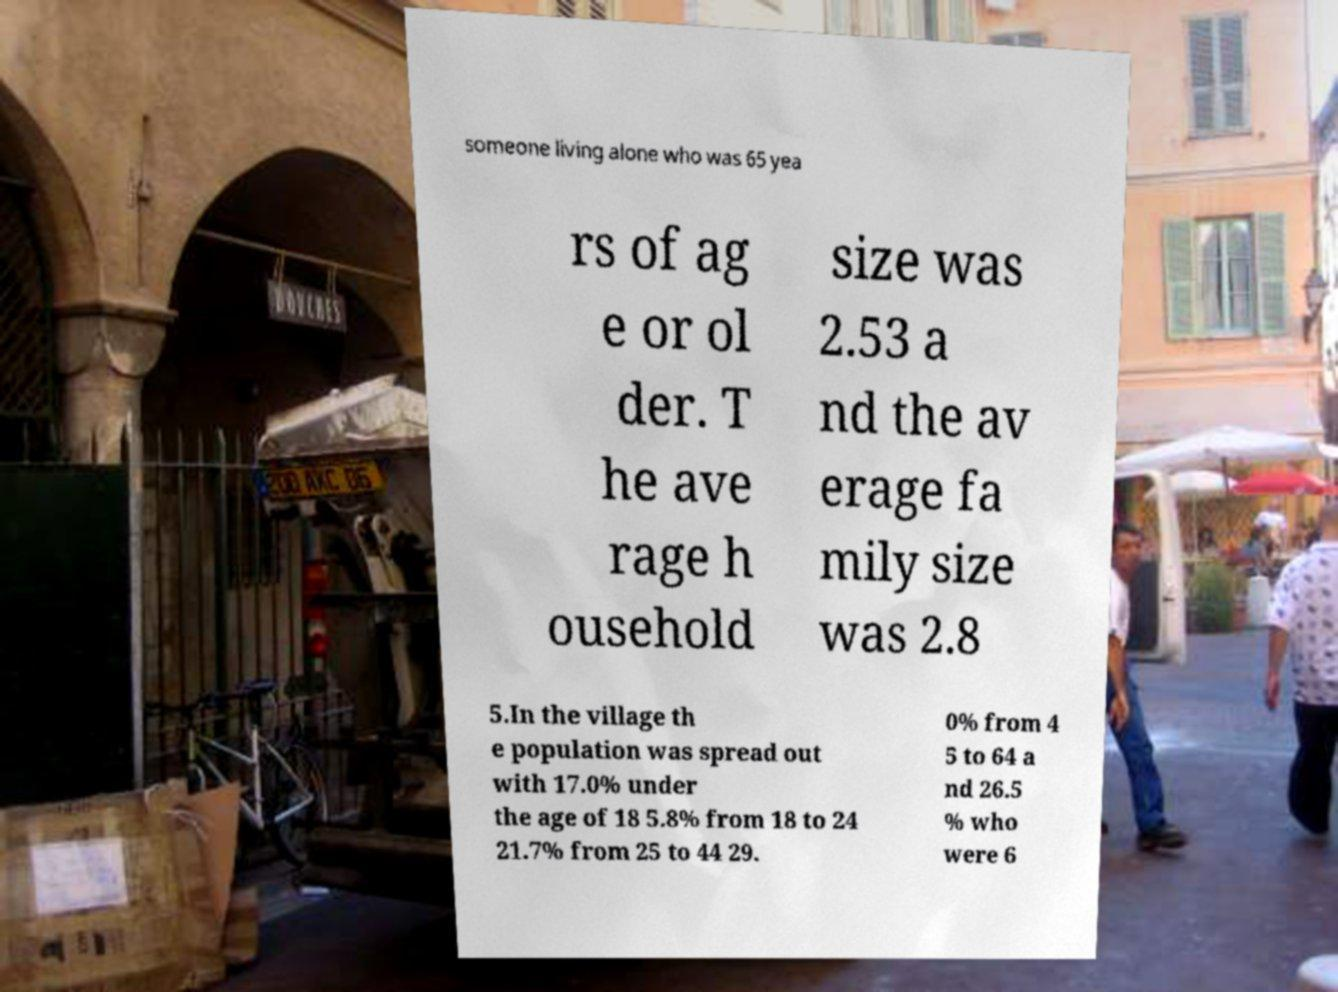Please identify and transcribe the text found in this image. someone living alone who was 65 yea rs of ag e or ol der. T he ave rage h ousehold size was 2.53 a nd the av erage fa mily size was 2.8 5.In the village th e population was spread out with 17.0% under the age of 18 5.8% from 18 to 24 21.7% from 25 to 44 29. 0% from 4 5 to 64 a nd 26.5 % who were 6 